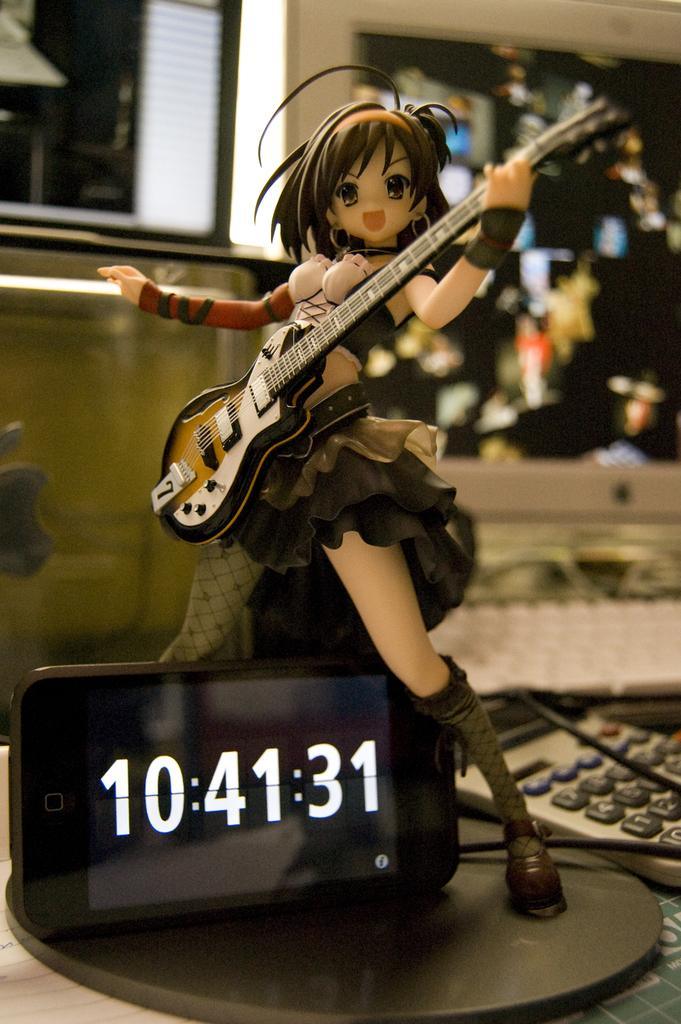What is the toy holding in the image? The toy is holding a guitar. What can be seen on the mobile in the image? The mobile is showing time. What device is visible in the image that is used for calculations? There is a calculator visible in the image. How many cars are parked in the jail in the image? There are no cars or jails present in the image. Who is the representative of the toy in the image? The image does not depict a toy representative, as it is not a political or organizational context. 